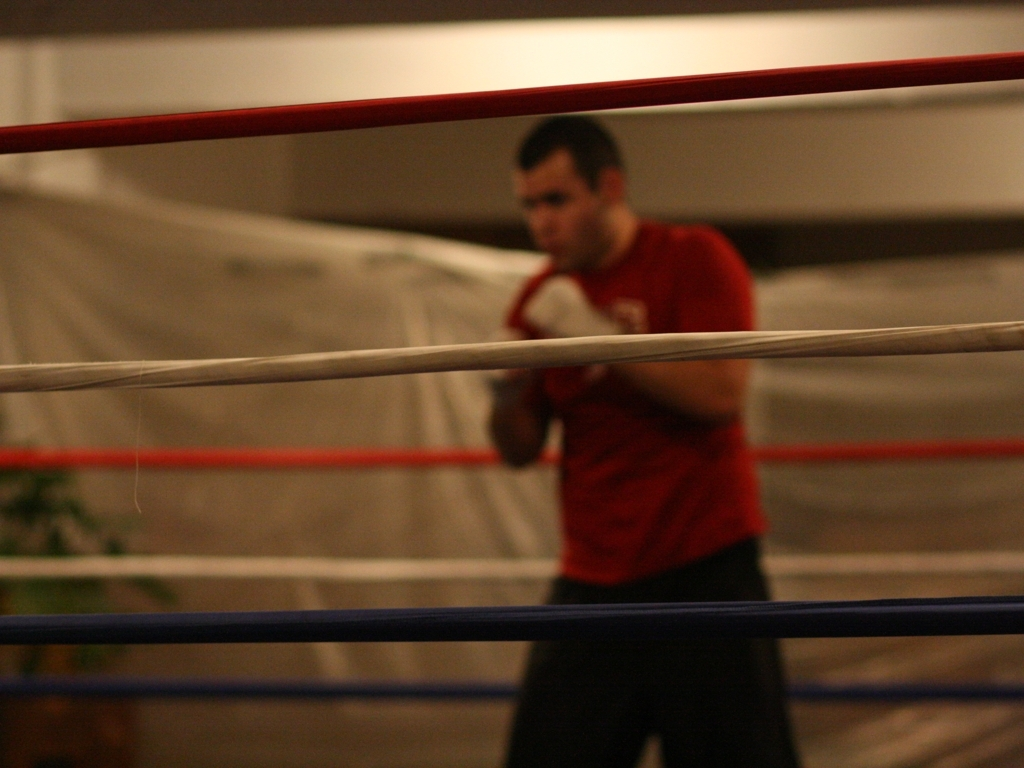Can you describe the lighting and atmosphere? The lighting in the image gives a dim and focused ambiance, with the subject partially illuminated. There is a soft, indirect light source that adds to the intensity and concentration visible on the person's face. 